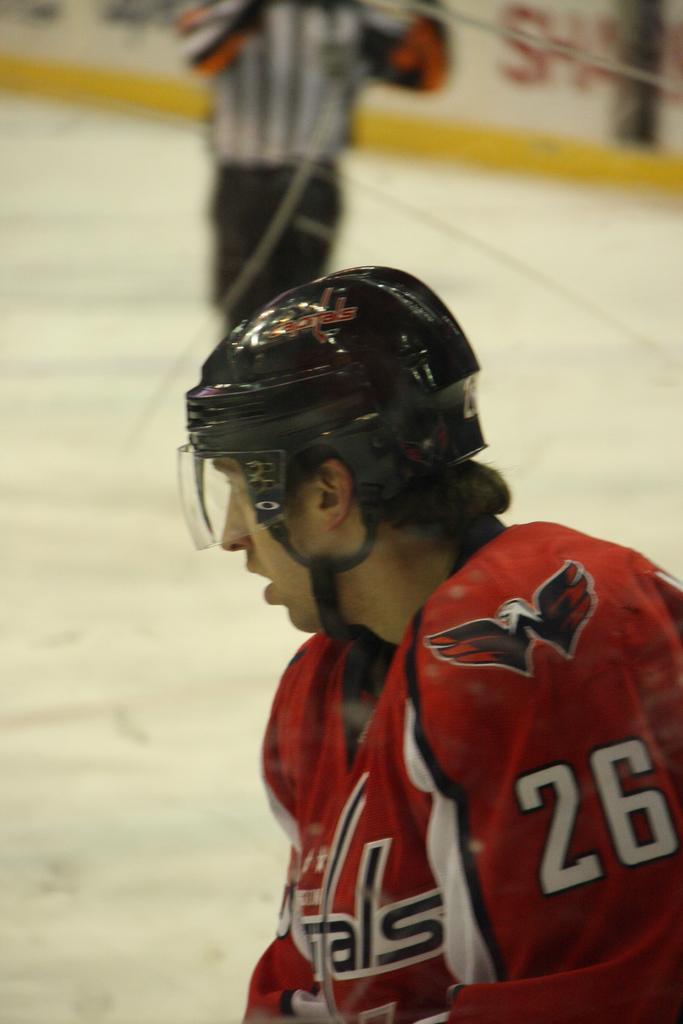Please provide a concise description of this image. In the center of the image there is a person wearing helmet. In the background we can see referee and advertisement. 